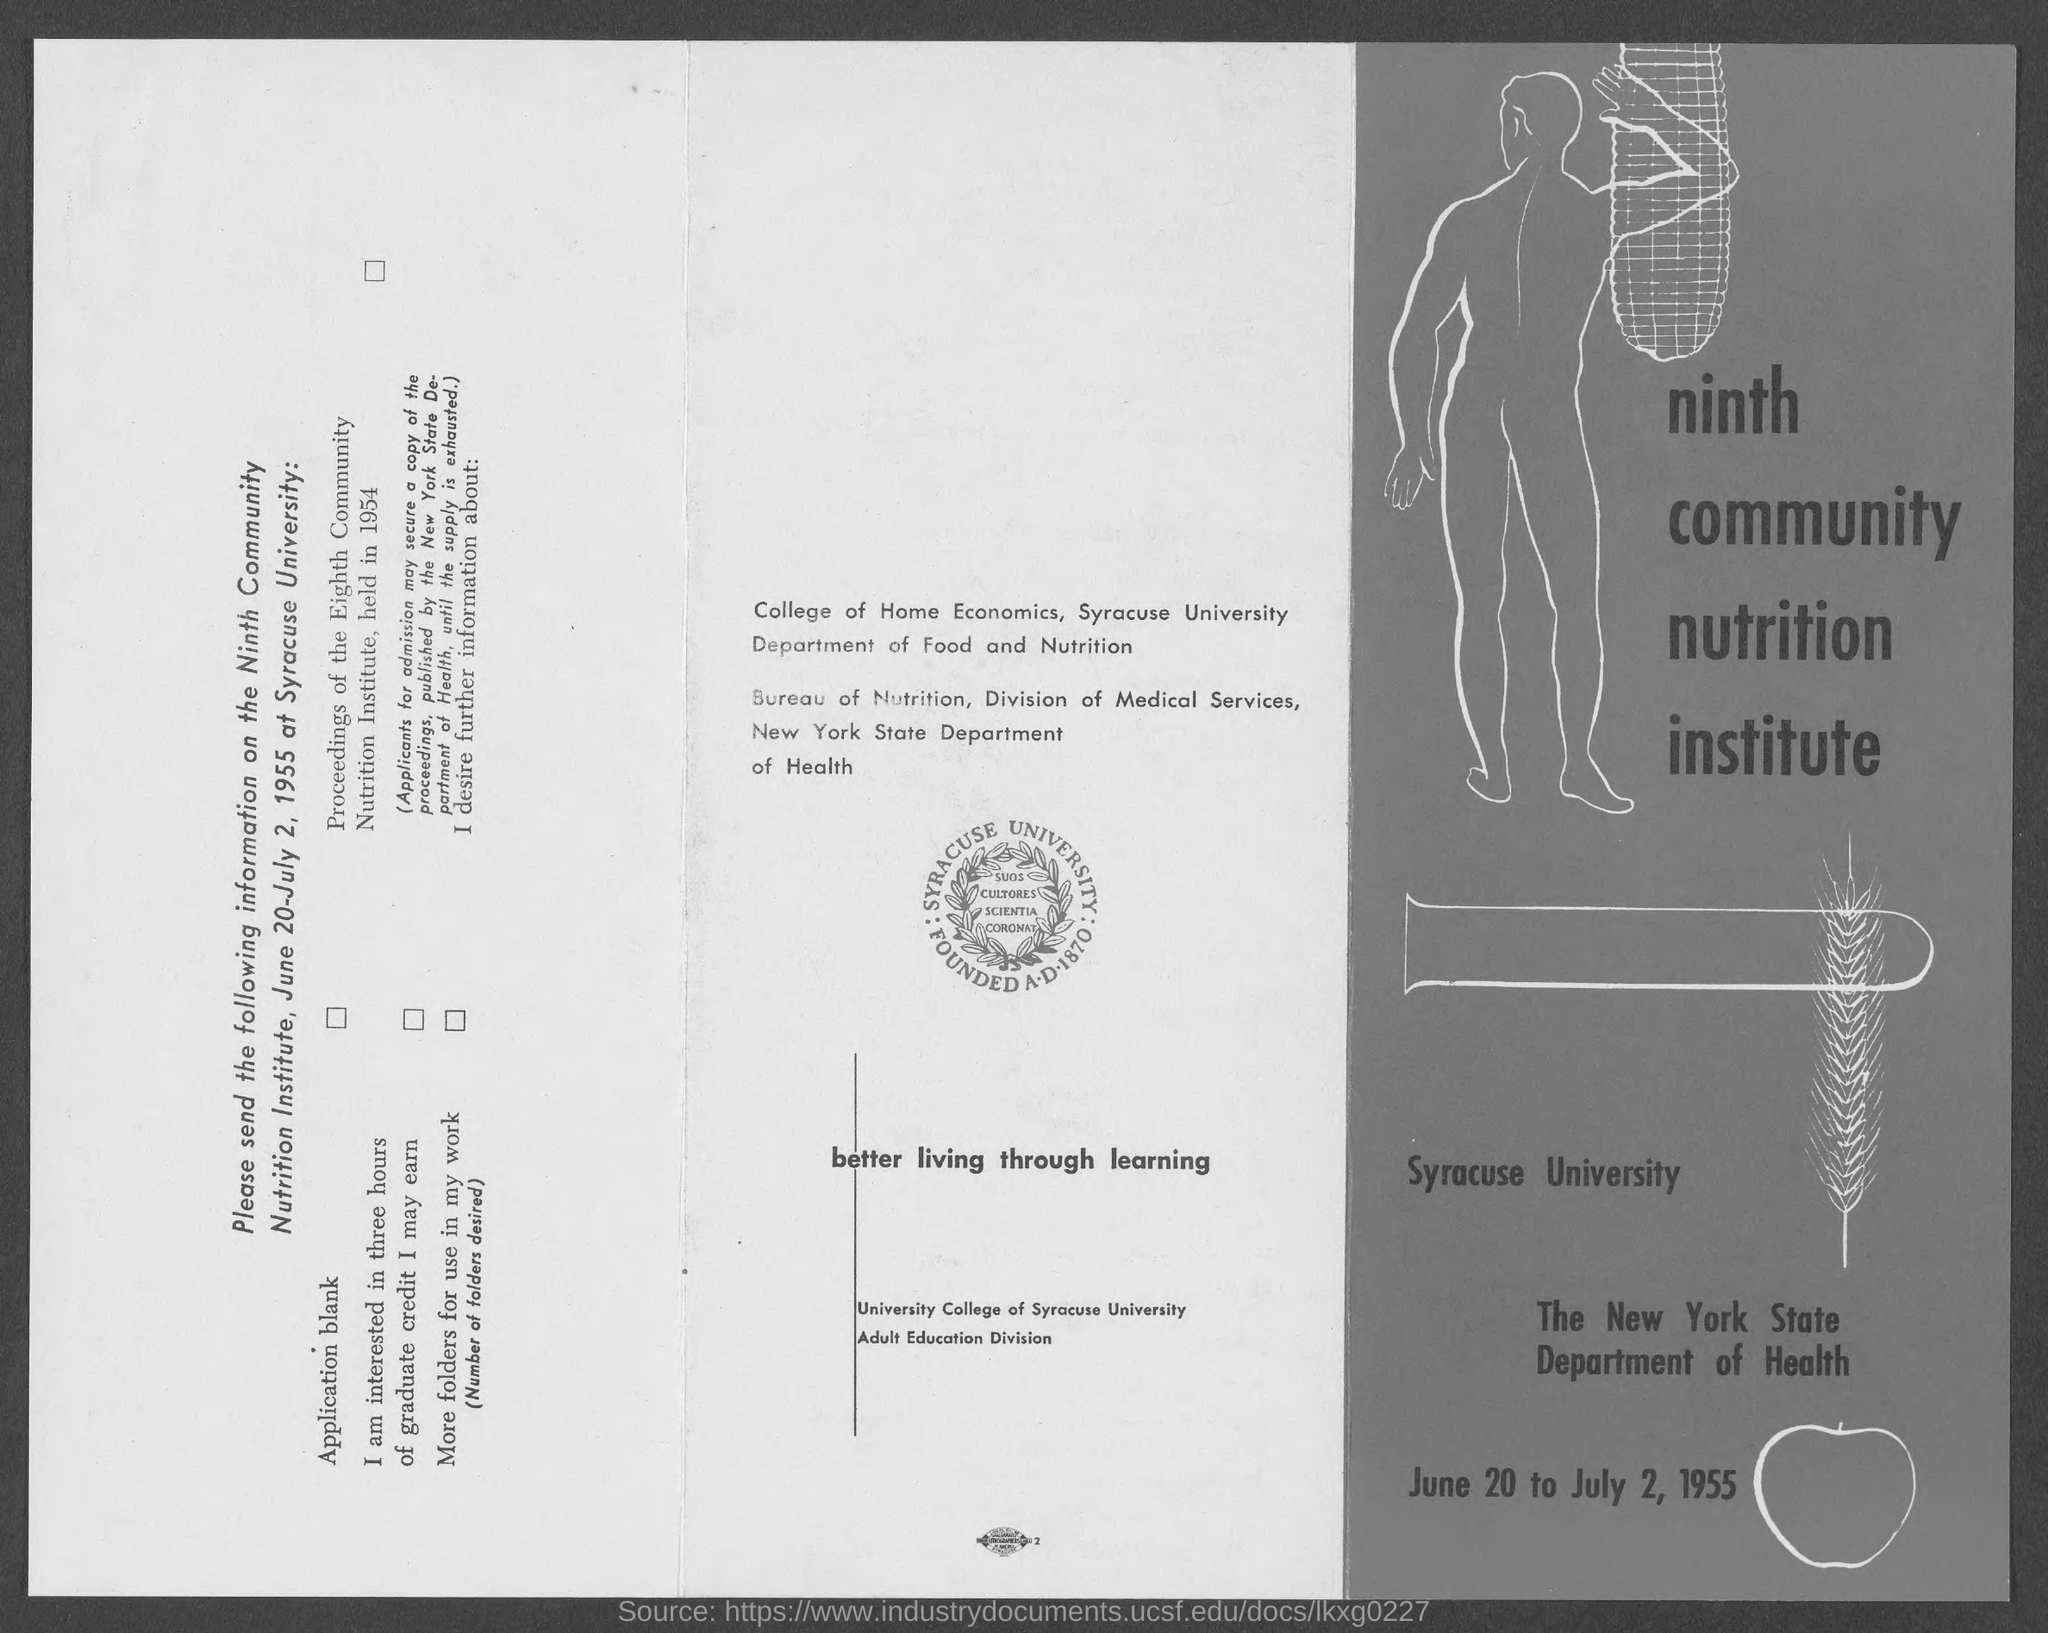Which University is mentioned in the picture?
Your answer should be very brief. Syracuse University. In Which State Syracuse University Located?
Keep it short and to the point. New York. 